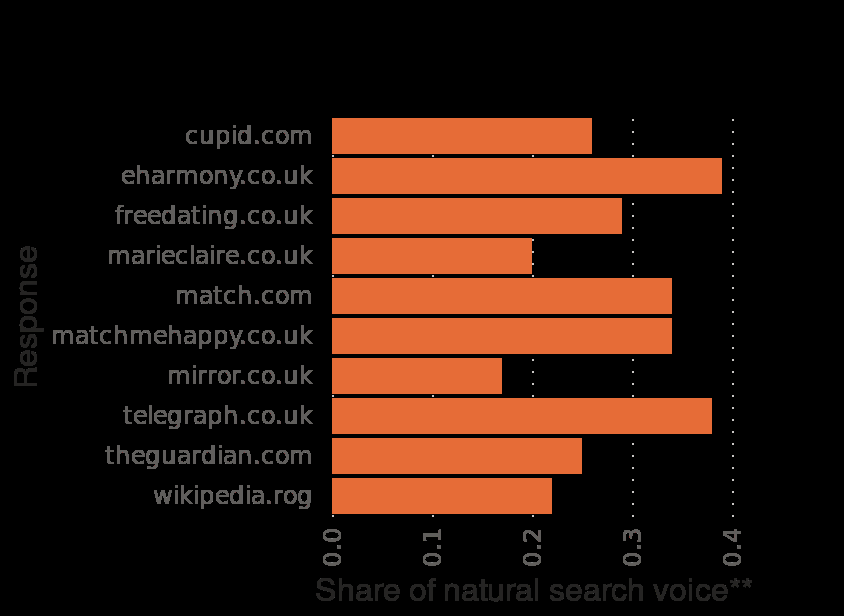<image>
What was the natural search voice share of EHarmony in February 2016?  The natural search voice share of EHarmony in February 2016 was 0.39. 